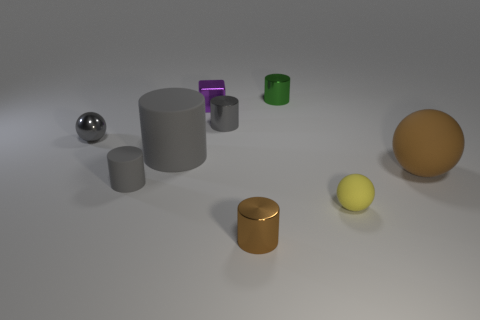How big is the brown sphere?
Your answer should be very brief. Large. Is the material of the object that is in front of the yellow object the same as the big brown thing?
Make the answer very short. No. Does the purple thing have the same shape as the green thing?
Keep it short and to the point. No. There is a large matte thing that is to the right of the brown thing to the left of the large object to the right of the green metallic cylinder; what shape is it?
Provide a short and direct response. Sphere. There is a big thing that is right of the green thing; is it the same shape as the brown object in front of the brown rubber object?
Keep it short and to the point. No. Is there another tiny thing that has the same material as the yellow thing?
Give a very brief answer. Yes. What is the color of the big matte object right of the tiny metal object in front of the small sphere that is behind the small gray matte thing?
Ensure brevity in your answer.  Brown. Are the small cylinder on the left side of the purple cube and the sphere that is in front of the tiny gray matte cylinder made of the same material?
Your response must be concise. Yes. What shape is the brown object left of the tiny green object?
Give a very brief answer. Cylinder. How many things are big brown rubber things or metallic objects that are behind the large gray rubber cylinder?
Provide a succinct answer. 5. 